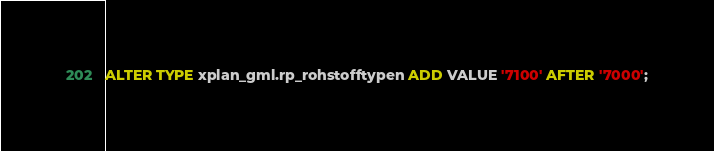<code> <loc_0><loc_0><loc_500><loc_500><_SQL_>ALTER TYPE xplan_gml.rp_rohstofftypen ADD VALUE '7100' AFTER '7000';</code> 